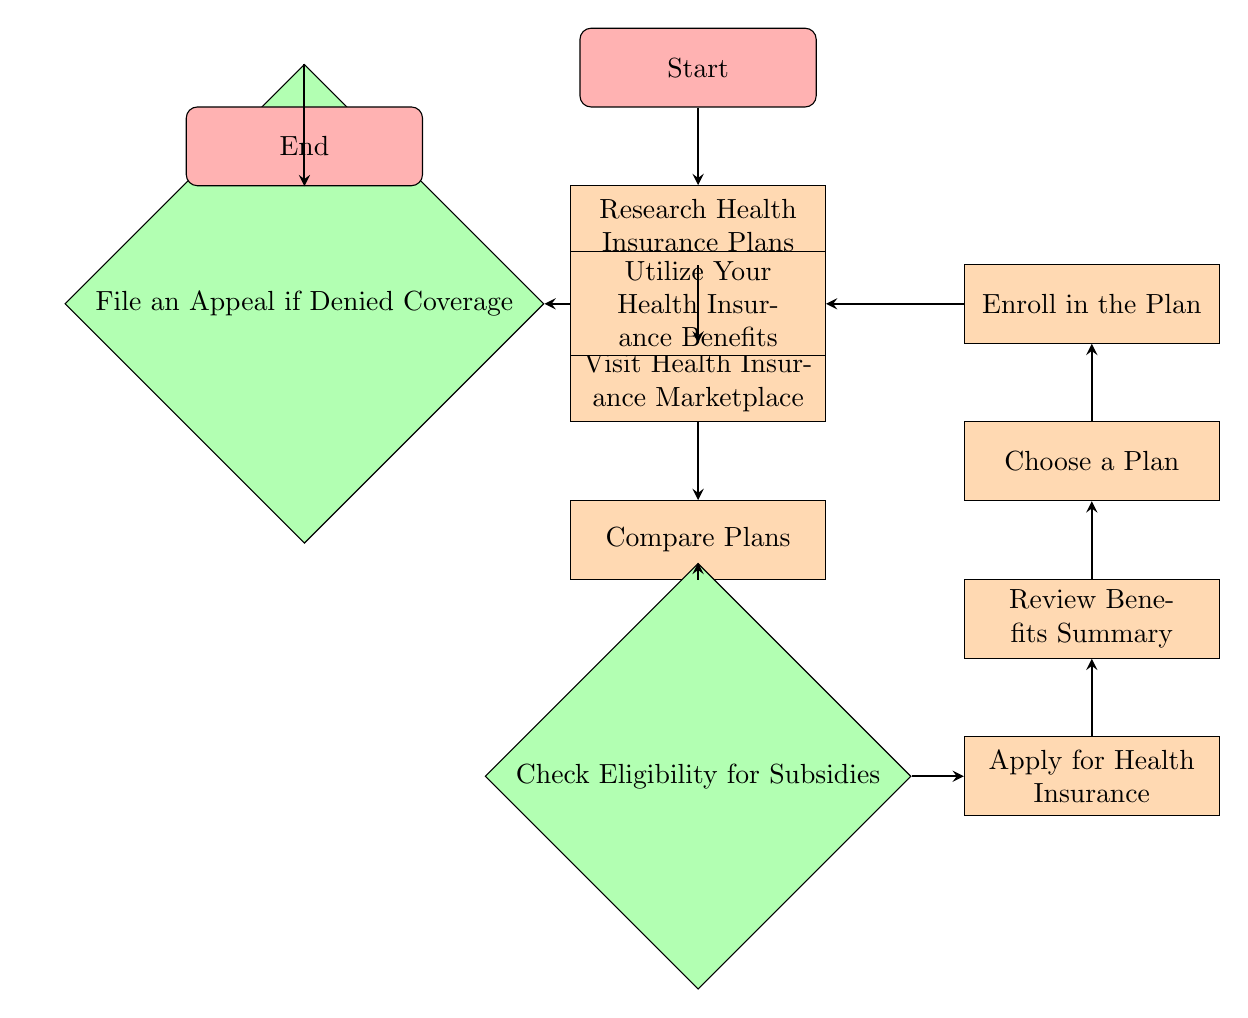What is the first step in the process? The diagram begins with the node labeled "Start," indicating that the first step is to start the process.
Answer: Start How many nodes are there in total? By counting each distinct labeled node in the diagram, there are 12 nodes represented.
Answer: 12 What action follows "Research Health Insurance Plans"? The flow from the "Research Health Insurance Plans" node continues to the "Visit Health Insurance Marketplace" node, indicating that this is the next action in the process.
Answer: Visit Health Insurance Marketplace Which step comes after checking eligibility for subsidies? The flow chart shows that after checking eligibility for subsidies, the next step is to "Apply for Health Insurance." This indicates the sequential nature of the process.
Answer: Apply for Health Insurance What are the last two actions before reaching the end? By tracing the flow from the final actions, the last two steps before reaching the "End" node are "File an Appeal if Denied Coverage" followed by "Utilize Your Health Insurance Benefits."
Answer: File an Appeal if Denied Coverage and Utilize Your Health Insurance Benefits What happens if one decides not to check for subsidies? Skipping the "Check Eligibility for Subsidies" node would mean one would not apply for health insurance, directly impacting the remaining steps that follow this decision. This indicates the importance of checking such eligibility.
Answer: Apply for Health Insurance is skipped What is the main purpose of the "Review Benefits Summary" step? The "Review Benefits Summary" step allows applicants to understand the specific benefits and coverage of the plan they have chosen before they finalize their enrollment.
Answer: Understand benefits What is the purpose of the "File an Appeal if Denied Coverage" step? This step is for those who have been denied coverage to formally contest the decision, indicating that there is a way to address potential issues with insurance applications.
Answer: Contest denial How many edges connect the nodes? The diagram has 11 edges that connect the various steps or actions in the flow of applying for health insurance.
Answer: 11 